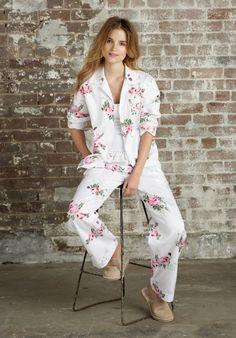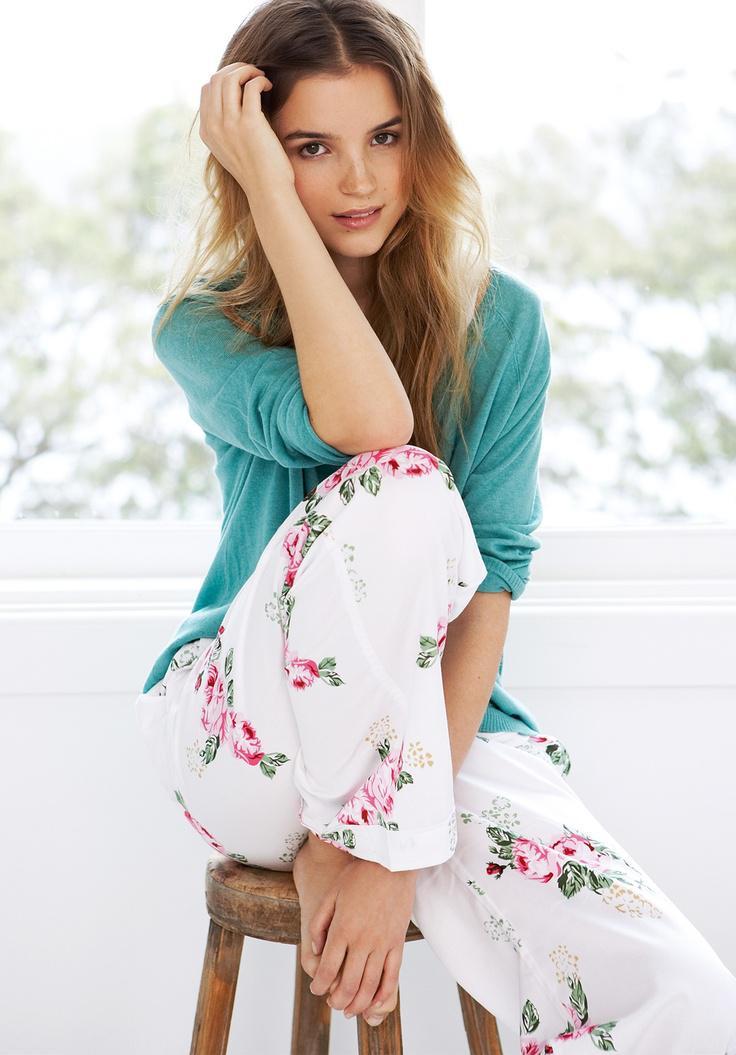The first image is the image on the left, the second image is the image on the right. Considering the images on both sides, is "The woman in one of the images has at least one hand on her knee." valid? Answer yes or no. No. The first image is the image on the left, the second image is the image on the right. Considering the images on both sides, is "An image features a model wearing matching white pajamas printed with rosy flowers and green leaves." valid? Answer yes or no. Yes. 